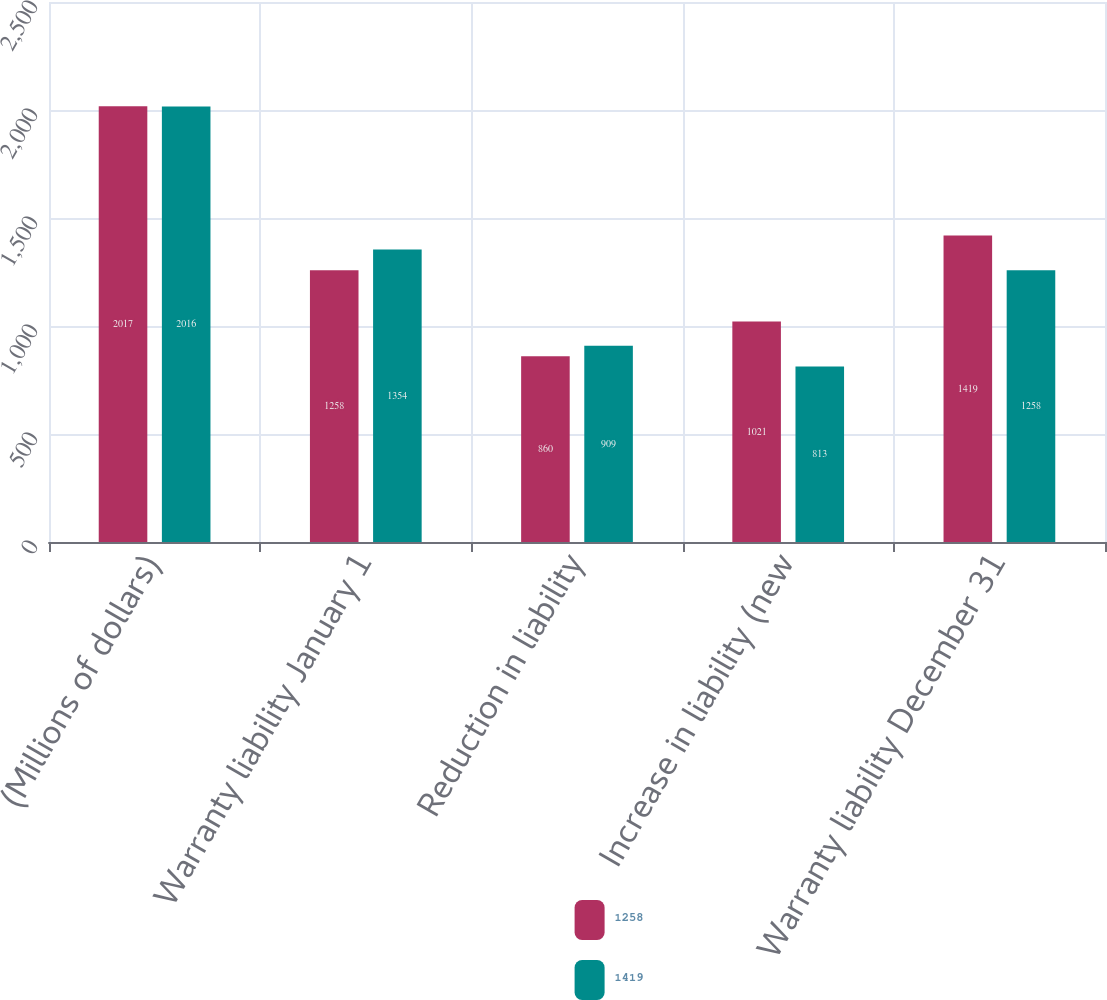<chart> <loc_0><loc_0><loc_500><loc_500><stacked_bar_chart><ecel><fcel>(Millions of dollars)<fcel>Warranty liability January 1<fcel>Reduction in liability<fcel>Increase in liability (new<fcel>Warranty liability December 31<nl><fcel>1258<fcel>2017<fcel>1258<fcel>860<fcel>1021<fcel>1419<nl><fcel>1419<fcel>2016<fcel>1354<fcel>909<fcel>813<fcel>1258<nl></chart> 